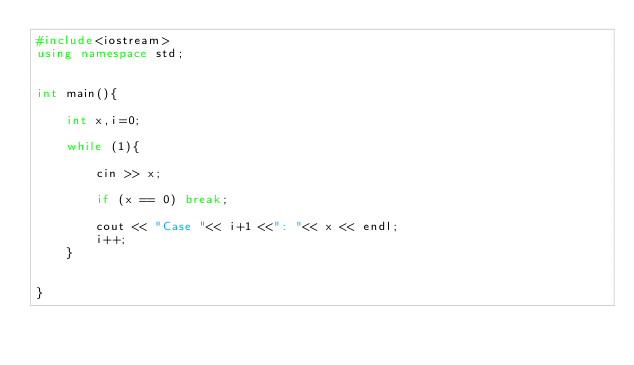<code> <loc_0><loc_0><loc_500><loc_500><_C++_>#include<iostream>
using namespace std;


int main(){

	int x,i=0;

	while (1){

		cin >> x;
		
		if (x == 0) break;

		cout << "Case "<< i+1 <<": "<< x << endl;
		i++;
	}


}</code> 